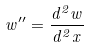<formula> <loc_0><loc_0><loc_500><loc_500>w ^ { \prime \prime } = \frac { d ^ { 2 } w } { d ^ { 2 } x }</formula> 